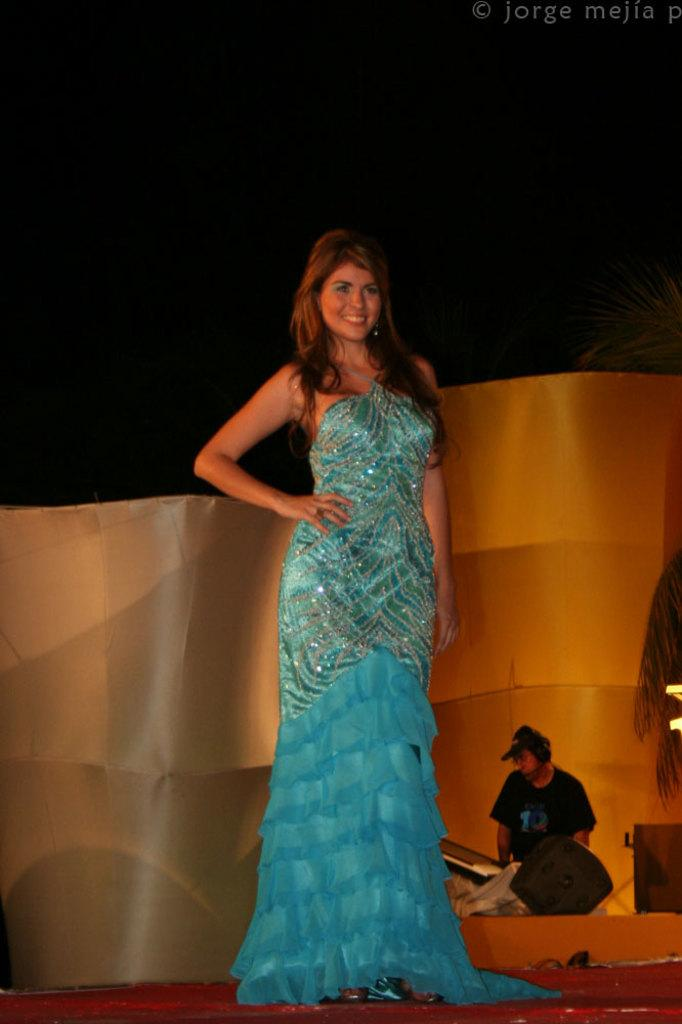Who is present in the image? There is a woman in the image. What is the woman wearing? The woman is wearing a blue dress. Where is the woman located in the image? The woman is standing on a stage. Can you describe the person next to the woman? There is a person wearing a cap in the image. What is in front of the person wearing a cap? There are objects in front of the person wearing a cap. What can be seen in the background of the image? There is a wall visible in the background of the image. What color is the paint on the shop's sign in the image? There is no shop or sign present in the image, so it is not possible to determine the color of any paint. 